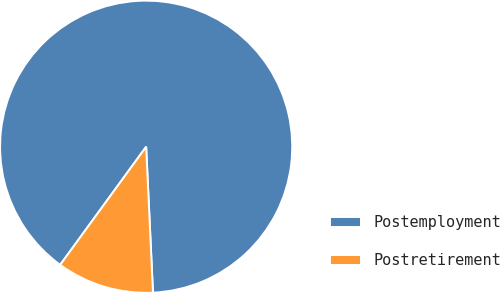<chart> <loc_0><loc_0><loc_500><loc_500><pie_chart><fcel>Postemployment<fcel>Postretirement<nl><fcel>89.24%<fcel>10.76%<nl></chart> 